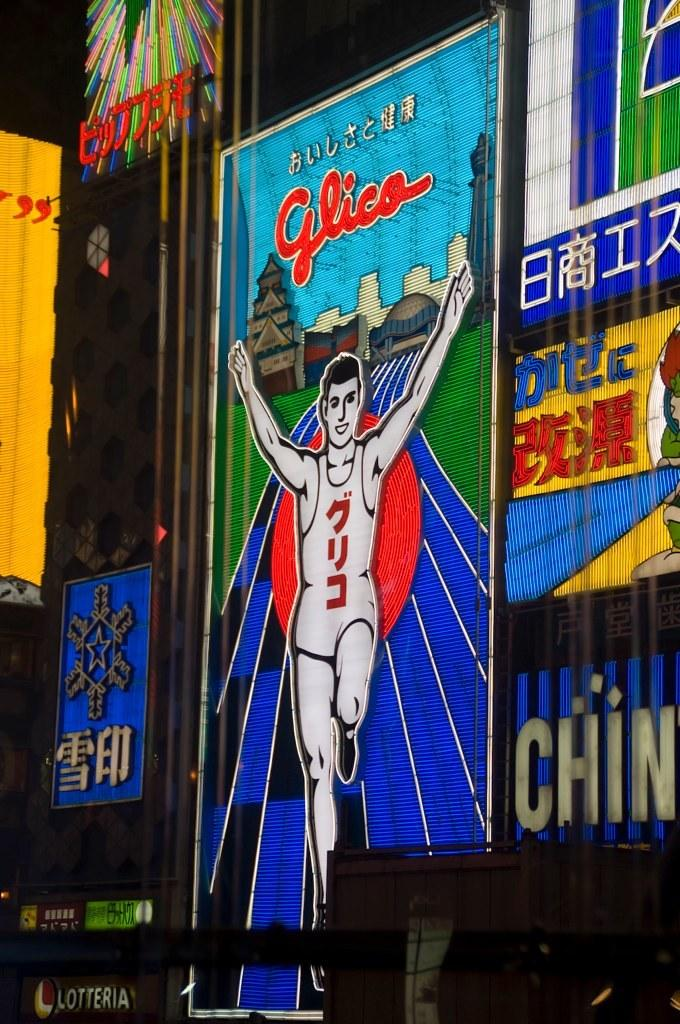<image>
Share a concise interpretation of the image provided. A neon sign depicting a track athlete hands above his head in celebration underneath some foreign writing and the word Glica. 